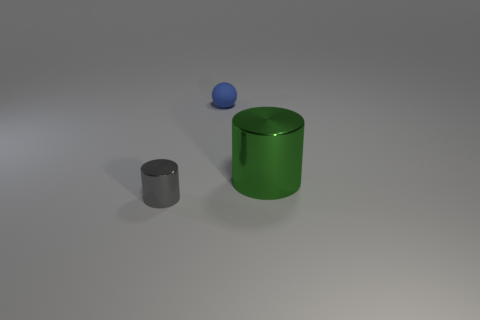Add 3 small blue cylinders. How many objects exist? 6 Subtract all balls. How many objects are left? 2 Subtract all tiny gray metallic cylinders. Subtract all gray things. How many objects are left? 1 Add 3 rubber things. How many rubber things are left? 4 Add 1 small cyan metallic spheres. How many small cyan metallic spheres exist? 1 Subtract 1 gray cylinders. How many objects are left? 2 